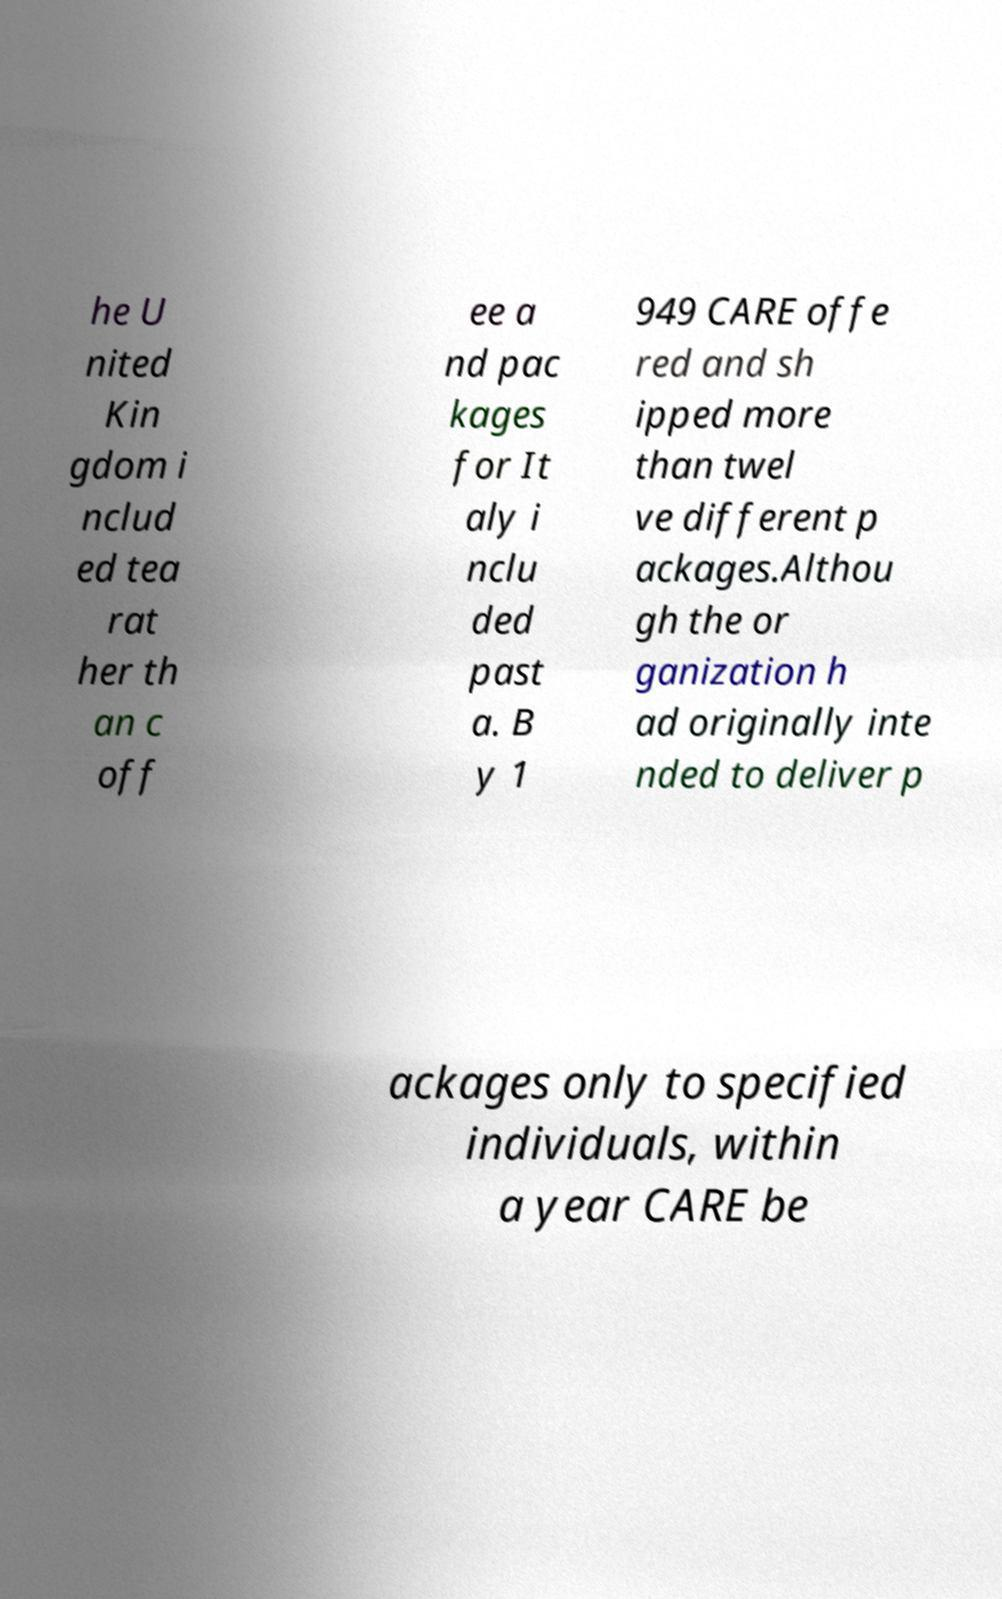What messages or text are displayed in this image? I need them in a readable, typed format. he U nited Kin gdom i nclud ed tea rat her th an c off ee a nd pac kages for It aly i nclu ded past a. B y 1 949 CARE offe red and sh ipped more than twel ve different p ackages.Althou gh the or ganization h ad originally inte nded to deliver p ackages only to specified individuals, within a year CARE be 